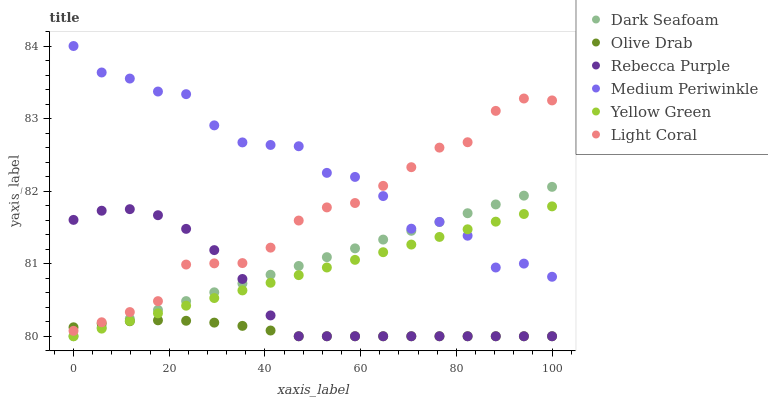Does Olive Drab have the minimum area under the curve?
Answer yes or no. Yes. Does Medium Periwinkle have the maximum area under the curve?
Answer yes or no. Yes. Does Light Coral have the minimum area under the curve?
Answer yes or no. No. Does Light Coral have the maximum area under the curve?
Answer yes or no. No. Is Yellow Green the smoothest?
Answer yes or no. Yes. Is Medium Periwinkle the roughest?
Answer yes or no. Yes. Is Light Coral the smoothest?
Answer yes or no. No. Is Light Coral the roughest?
Answer yes or no. No. Does Yellow Green have the lowest value?
Answer yes or no. Yes. Does Light Coral have the lowest value?
Answer yes or no. No. Does Medium Periwinkle have the highest value?
Answer yes or no. Yes. Does Light Coral have the highest value?
Answer yes or no. No. Is Rebecca Purple less than Medium Periwinkle?
Answer yes or no. Yes. Is Light Coral greater than Dark Seafoam?
Answer yes or no. Yes. Does Rebecca Purple intersect Dark Seafoam?
Answer yes or no. Yes. Is Rebecca Purple less than Dark Seafoam?
Answer yes or no. No. Is Rebecca Purple greater than Dark Seafoam?
Answer yes or no. No. Does Rebecca Purple intersect Medium Periwinkle?
Answer yes or no. No. 